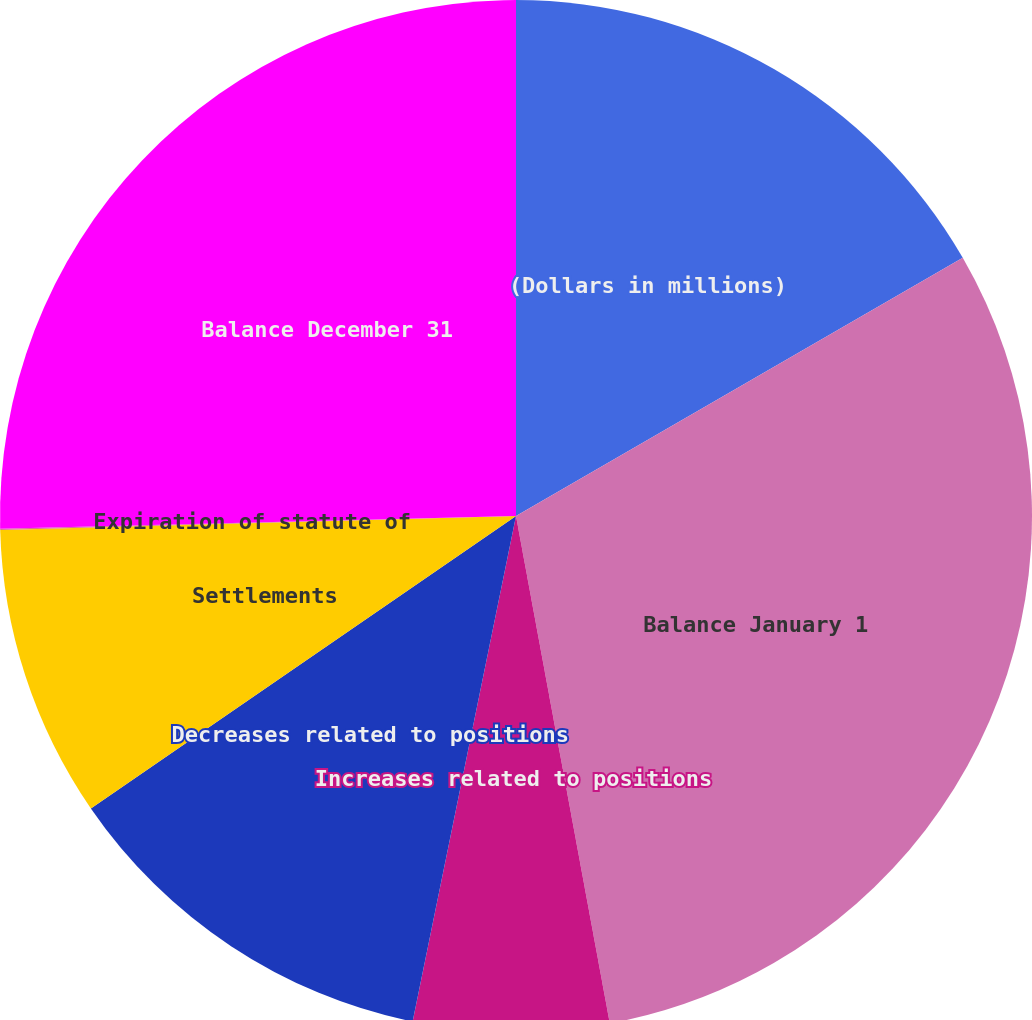Convert chart. <chart><loc_0><loc_0><loc_500><loc_500><pie_chart><fcel>(Dollars in millions)<fcel>Balance January 1<fcel>Increases related to positions<fcel>Decreases related to positions<fcel>Settlements<fcel>Expiration of statute of<fcel>Balance December 31<nl><fcel>16.66%<fcel>30.43%<fcel>6.12%<fcel>12.2%<fcel>9.16%<fcel>0.04%<fcel>25.39%<nl></chart> 